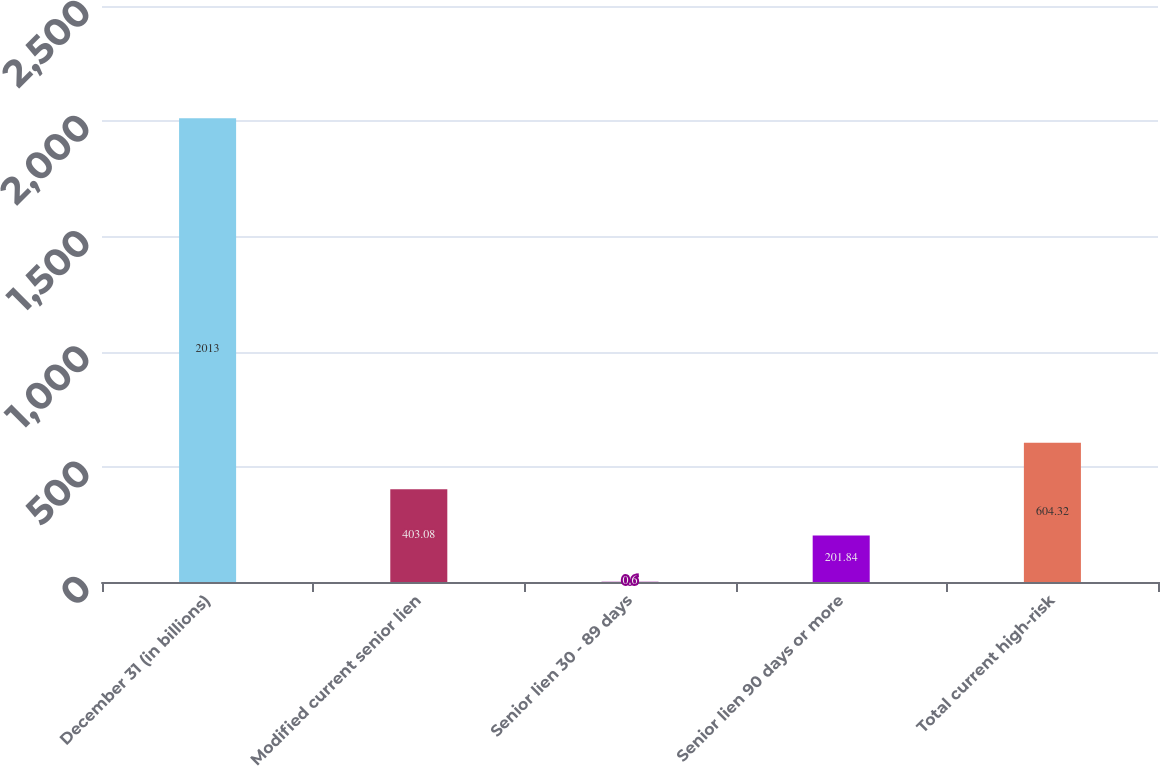Convert chart to OTSL. <chart><loc_0><loc_0><loc_500><loc_500><bar_chart><fcel>December 31 (in billions)<fcel>Modified current senior lien<fcel>Senior lien 30 - 89 days<fcel>Senior lien 90 days or more<fcel>Total current high-risk<nl><fcel>2013<fcel>403.08<fcel>0.6<fcel>201.84<fcel>604.32<nl></chart> 